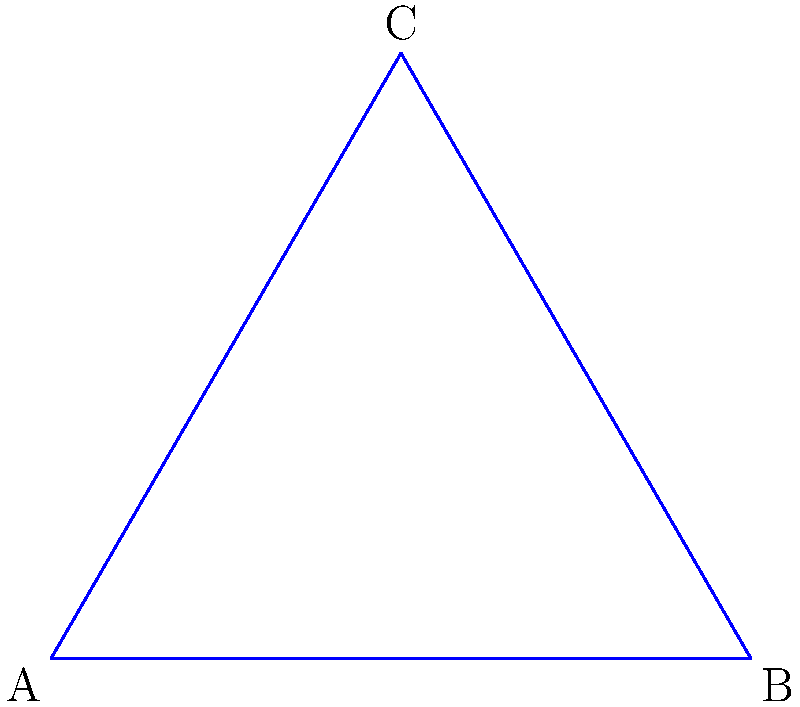In the context of Non-Euclidean Geometry, consider the triangles shown above: one on a flat plane (blue) and one on a sphere (red). How does the sum of interior angles in the spherical triangle compare to that of the flat triangle, and what historical significance might this have had for early Australian navigators and explorers? To understand the difference between triangles on a flat plane and a sphere, let's break it down step-by-step:

1. Flat plane triangle:
   - In Euclidean geometry, the sum of interior angles of a triangle is always 180°.
   - This is represented by the formula: $\alpha + \beta + \gamma = 180°$, where $\alpha$, $\beta$, and $\gamma$ are the interior angles.

2. Spherical triangle:
   - On a sphere, the sum of interior angles of a triangle is always greater than 180°.
   - The formula for a spherical triangle is: $\alpha + \beta + \gamma = 180° + \epsilon$, where $\epsilon$ is the spherical excess.
   - The spherical excess is proportional to the area of the triangle on the sphere's surface.

3. Comparison:
   - The sum of angles in a spherical triangle is always greater than 180°.
   - The larger the triangle on the sphere (relative to the sphere's size), the greater the excess.

4. Historical significance for Australian navigators and explorers:
   - Early explorers, including those charting Australia's coastline, relied heavily on celestial navigation.
   - Understanding spherical geometry was crucial for accurate navigation, as the Earth is (approximately) a sphere.
   - Navigators had to account for the curved surface of the Earth when plotting courses over long distances.
   - This knowledge allowed for more precise mapping of the Australian continent and surrounding waters.

5. Impact on Australian history:
   - Accurate navigation and mapping were essential for the exploration and settlement of Australia.
   - The ability to understand and apply spherical geometry contributed to the success of pioneering expeditions, both maritime and inland.
   - This mathematical knowledge indirectly influenced the patterns of early European settlement and the discovery of resources across the continent.
Answer: The sum of interior angles in the spherical triangle is greater than 180°, which was crucial for accurate navigation and mapping in early Australian exploration. 